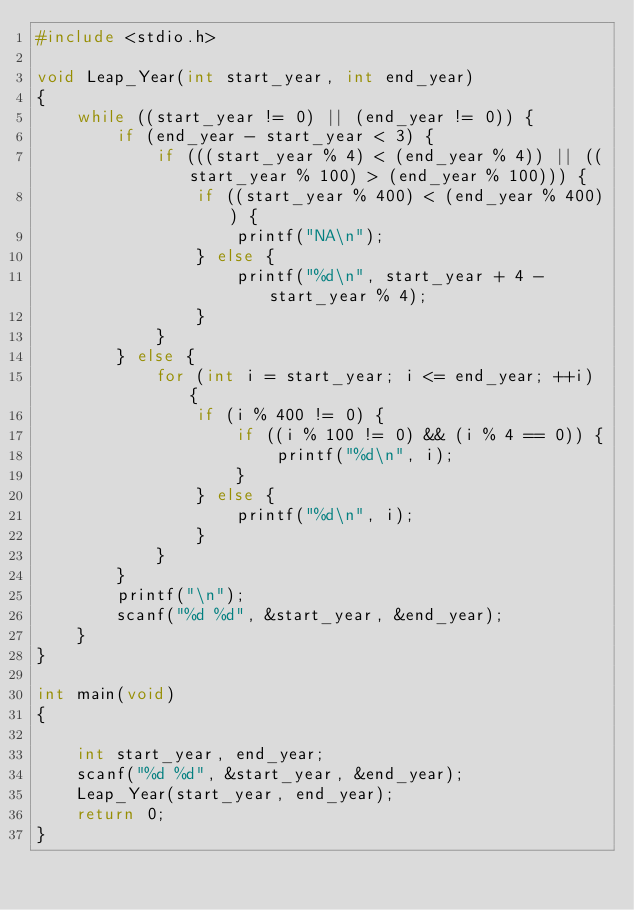Convert code to text. <code><loc_0><loc_0><loc_500><loc_500><_C++_>#include <stdio.h>

void Leap_Year(int start_year, int end_year)
{
    while ((start_year != 0) || (end_year != 0)) {
        if (end_year - start_year < 3) {
            if (((start_year % 4) < (end_year % 4)) || ((start_year % 100) > (end_year % 100))) { 
                if ((start_year % 400) < (end_year % 400)) {
                    printf("NA\n");
                } else {
                    printf("%d\n", start_year + 4 - start_year % 4);
                }
            }
        } else {
            for (int i = start_year; i <= end_year; ++i) {
                if (i % 400 != 0) {
                    if ((i % 100 != 0) && (i % 4 == 0)) {
                        printf("%d\n", i);
                    }
                } else {
                    printf("%d\n", i);
                }
            }
        }
        printf("\n");
        scanf("%d %d", &start_year, &end_year);
    }
}

int main(void)
{
    
    int start_year, end_year;
    scanf("%d %d", &start_year, &end_year);
    Leap_Year(start_year, end_year);
    return 0;
}</code> 